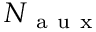Convert formula to latex. <formula><loc_0><loc_0><loc_500><loc_500>N _ { a u x }</formula> 